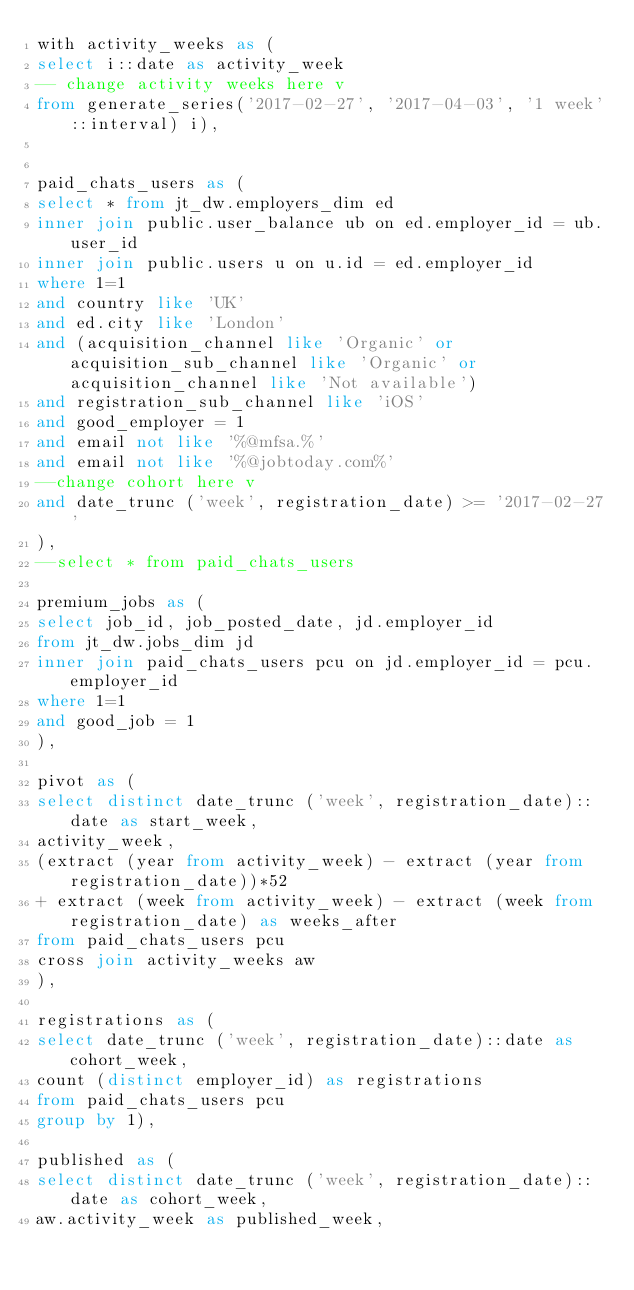<code> <loc_0><loc_0><loc_500><loc_500><_SQL_>with activity_weeks as (
select i::date as activity_week
-- change activity weeks here v
from generate_series('2017-02-27', '2017-04-03', '1 week'::interval) i),


paid_chats_users as (
select * from jt_dw.employers_dim ed
inner join public.user_balance ub on ed.employer_id = ub.user_id
inner join public.users u on u.id = ed.employer_id
where 1=1
and country like 'UK'
and ed.city like 'London'
and (acquisition_channel like 'Organic' or acquisition_sub_channel like 'Organic' or acquisition_channel like 'Not available')
and registration_sub_channel like 'iOS'
and good_employer = 1
and email not like '%@mfsa.%'
and email not like '%@jobtoday.com%'
--change cohort here v
and date_trunc ('week', registration_date) >= '2017-02-27'
),
--select * from paid_chats_users

premium_jobs as (
select job_id, job_posted_date, jd.employer_id
from jt_dw.jobs_dim jd
inner join paid_chats_users pcu on jd.employer_id = pcu.employer_id
where 1=1
and good_job = 1
),

pivot as (
select distinct date_trunc ('week', registration_date)::date as start_week,
activity_week,
(extract (year from activity_week) - extract (year from registration_date))*52 
+ extract (week from activity_week) - extract (week from registration_date) as weeks_after
from paid_chats_users pcu
cross join activity_weeks aw
),

registrations as (
select date_trunc ('week', registration_date)::date as cohort_week,
count (distinct employer_id) as registrations
from paid_chats_users pcu
group by 1),

published as (
select distinct date_trunc ('week', registration_date)::date as cohort_week,
aw.activity_week as published_week,</code> 